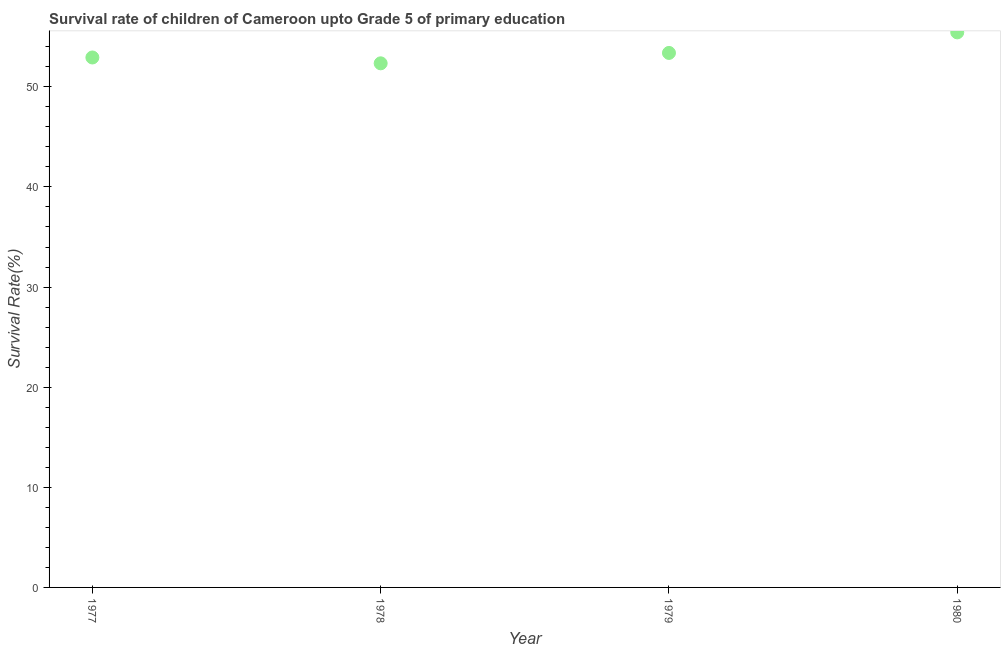What is the survival rate in 1977?
Your answer should be very brief. 52.93. Across all years, what is the maximum survival rate?
Provide a short and direct response. 55.44. Across all years, what is the minimum survival rate?
Your answer should be very brief. 52.35. In which year was the survival rate maximum?
Give a very brief answer. 1980. In which year was the survival rate minimum?
Keep it short and to the point. 1978. What is the sum of the survival rate?
Provide a succinct answer. 214.11. What is the difference between the survival rate in 1977 and 1980?
Provide a short and direct response. -2.51. What is the average survival rate per year?
Your answer should be compact. 53.53. What is the median survival rate?
Offer a terse response. 53.16. In how many years, is the survival rate greater than 36 %?
Offer a very short reply. 4. What is the ratio of the survival rate in 1978 to that in 1980?
Your answer should be compact. 0.94. Is the difference between the survival rate in 1977 and 1978 greater than the difference between any two years?
Give a very brief answer. No. What is the difference between the highest and the second highest survival rate?
Provide a short and direct response. 2.05. Is the sum of the survival rate in 1977 and 1979 greater than the maximum survival rate across all years?
Your answer should be very brief. Yes. What is the difference between the highest and the lowest survival rate?
Provide a short and direct response. 3.09. How many dotlines are there?
Your answer should be very brief. 1. How many years are there in the graph?
Ensure brevity in your answer.  4. Are the values on the major ticks of Y-axis written in scientific E-notation?
Give a very brief answer. No. What is the title of the graph?
Your response must be concise. Survival rate of children of Cameroon upto Grade 5 of primary education. What is the label or title of the Y-axis?
Ensure brevity in your answer.  Survival Rate(%). What is the Survival Rate(%) in 1977?
Keep it short and to the point. 52.93. What is the Survival Rate(%) in 1978?
Ensure brevity in your answer.  52.35. What is the Survival Rate(%) in 1979?
Make the answer very short. 53.39. What is the Survival Rate(%) in 1980?
Provide a short and direct response. 55.44. What is the difference between the Survival Rate(%) in 1977 and 1978?
Your answer should be very brief. 0.58. What is the difference between the Survival Rate(%) in 1977 and 1979?
Your answer should be compact. -0.46. What is the difference between the Survival Rate(%) in 1977 and 1980?
Provide a short and direct response. -2.51. What is the difference between the Survival Rate(%) in 1978 and 1979?
Your answer should be very brief. -1.04. What is the difference between the Survival Rate(%) in 1978 and 1980?
Offer a terse response. -3.09. What is the difference between the Survival Rate(%) in 1979 and 1980?
Your answer should be very brief. -2.05. What is the ratio of the Survival Rate(%) in 1977 to that in 1978?
Provide a succinct answer. 1.01. What is the ratio of the Survival Rate(%) in 1977 to that in 1980?
Make the answer very short. 0.95. What is the ratio of the Survival Rate(%) in 1978 to that in 1979?
Make the answer very short. 0.98. What is the ratio of the Survival Rate(%) in 1978 to that in 1980?
Your response must be concise. 0.94. 